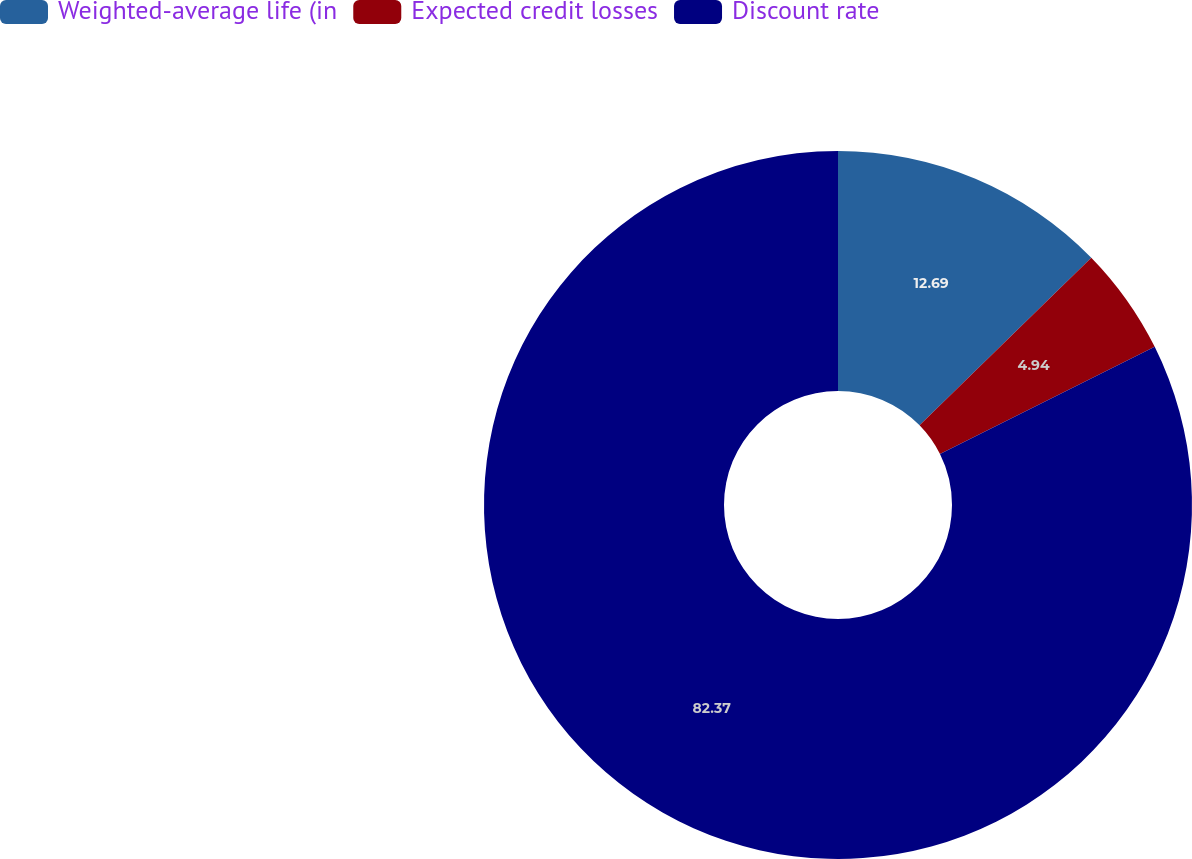Convert chart to OTSL. <chart><loc_0><loc_0><loc_500><loc_500><pie_chart><fcel>Weighted-average life (in<fcel>Expected credit losses<fcel>Discount rate<nl><fcel>12.69%<fcel>4.94%<fcel>82.37%<nl></chart> 